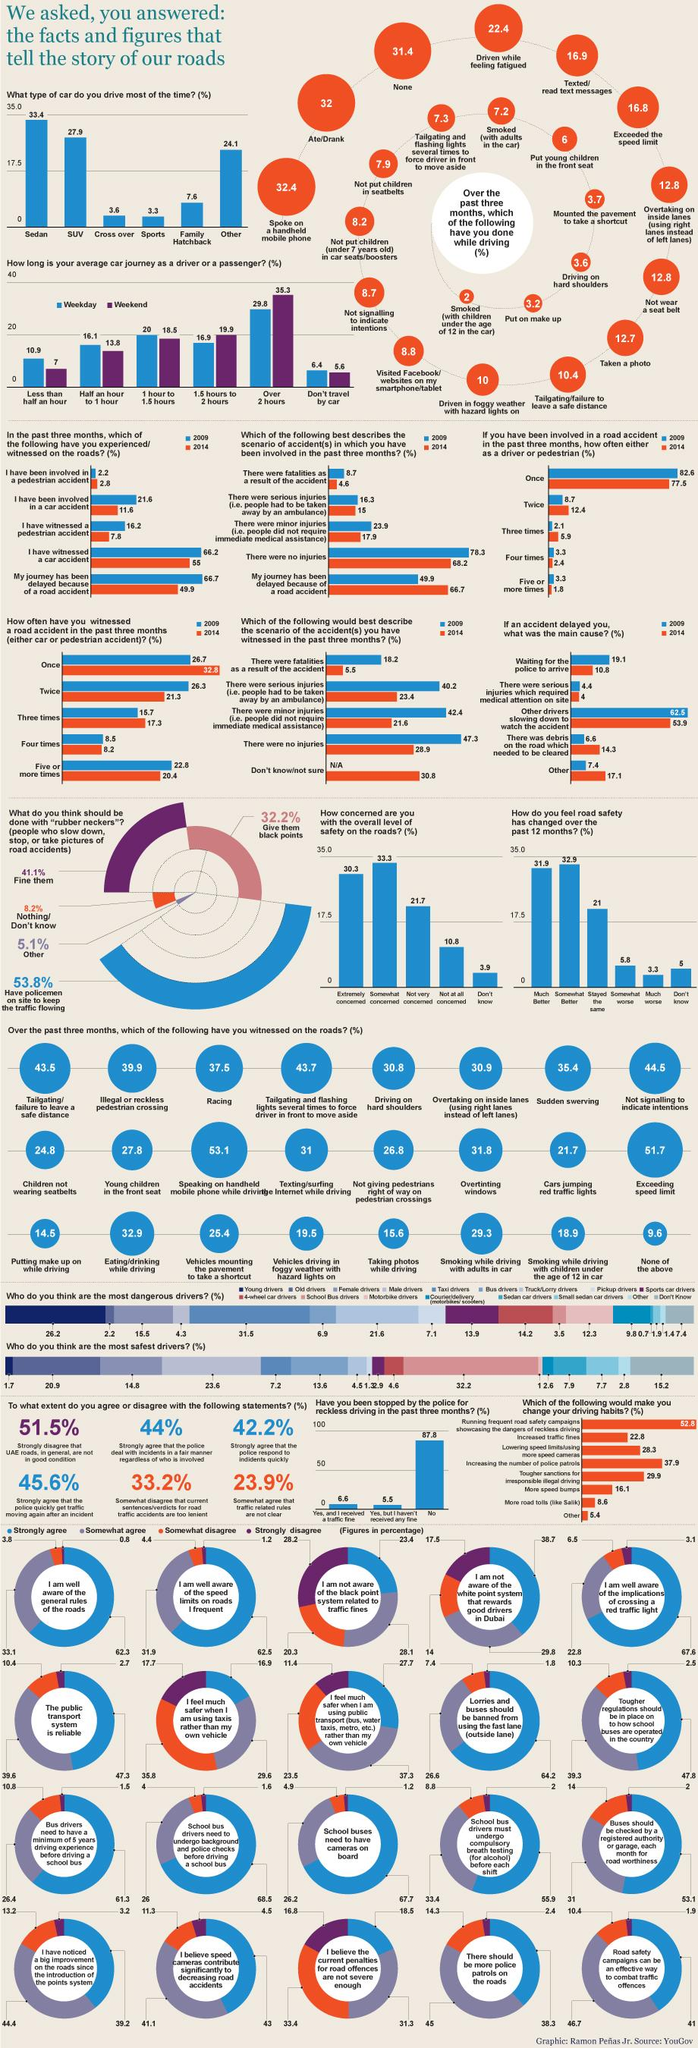Identify some key points in this picture. According to the given data, the percentage of cross over and sports when taken together is 6.9%. The percentage of racing and sudden swerving when taken together is 72.9%. The color that is typically used to represent the weekend is violet. 